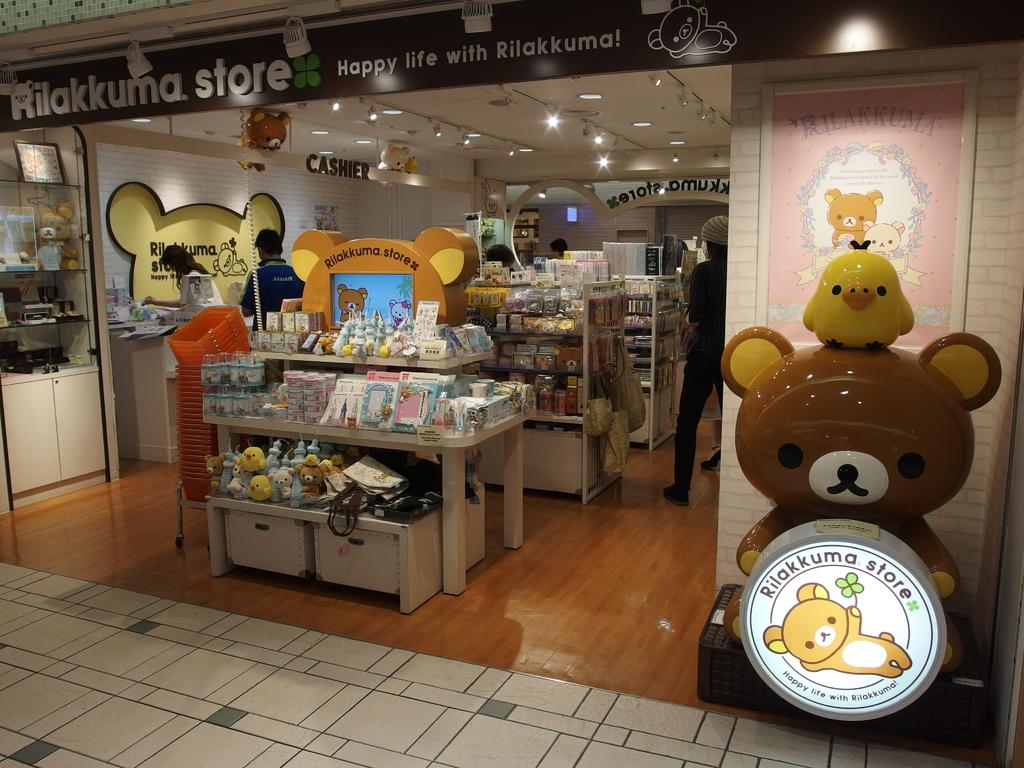What type of establishment is depicted in the image? The image appears to depict a store. What can be seen inside the store? There are items visible in the store. Can you describe one of the items in the store? There is an item in the shape of a teddy bear on the right side. Where is the sink located in the image? There is no sink present in the image. Can you point out the map in the image? There is no map present in the image. 